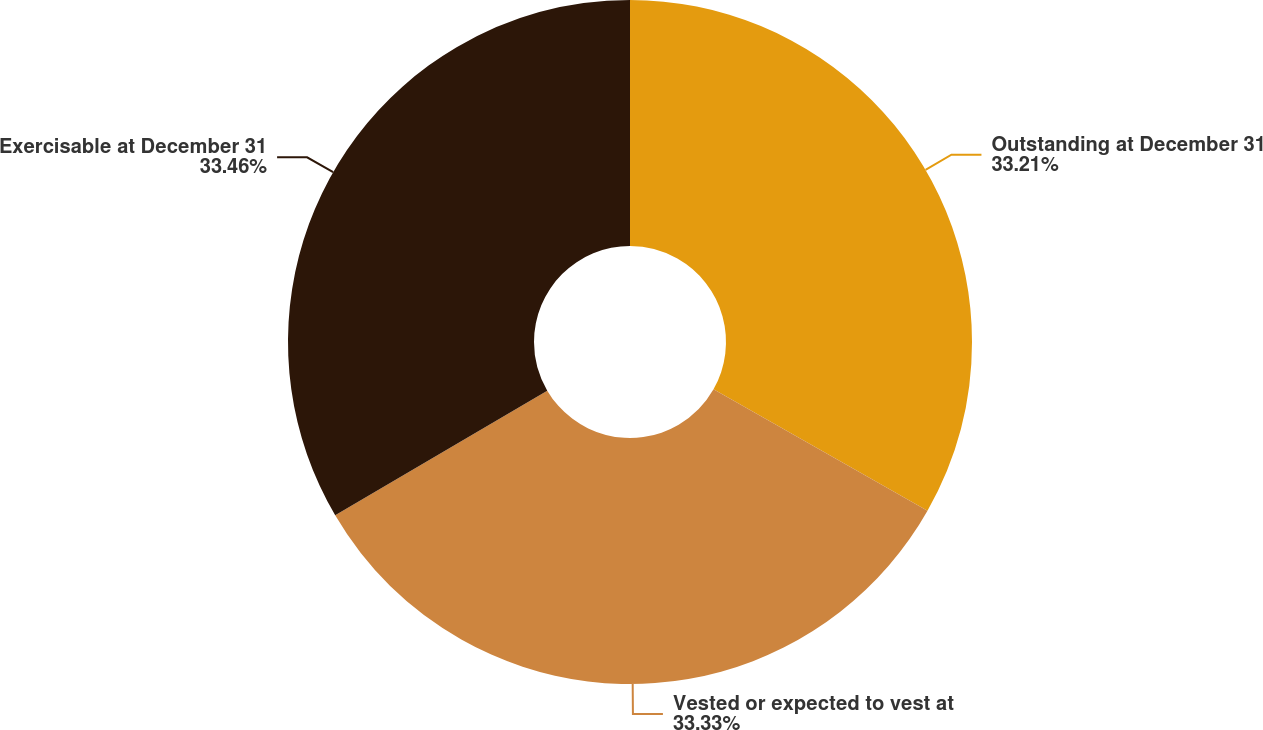<chart> <loc_0><loc_0><loc_500><loc_500><pie_chart><fcel>Outstanding at December 31<fcel>Vested or expected to vest at<fcel>Exercisable at December 31<nl><fcel>33.21%<fcel>33.33%<fcel>33.46%<nl></chart> 